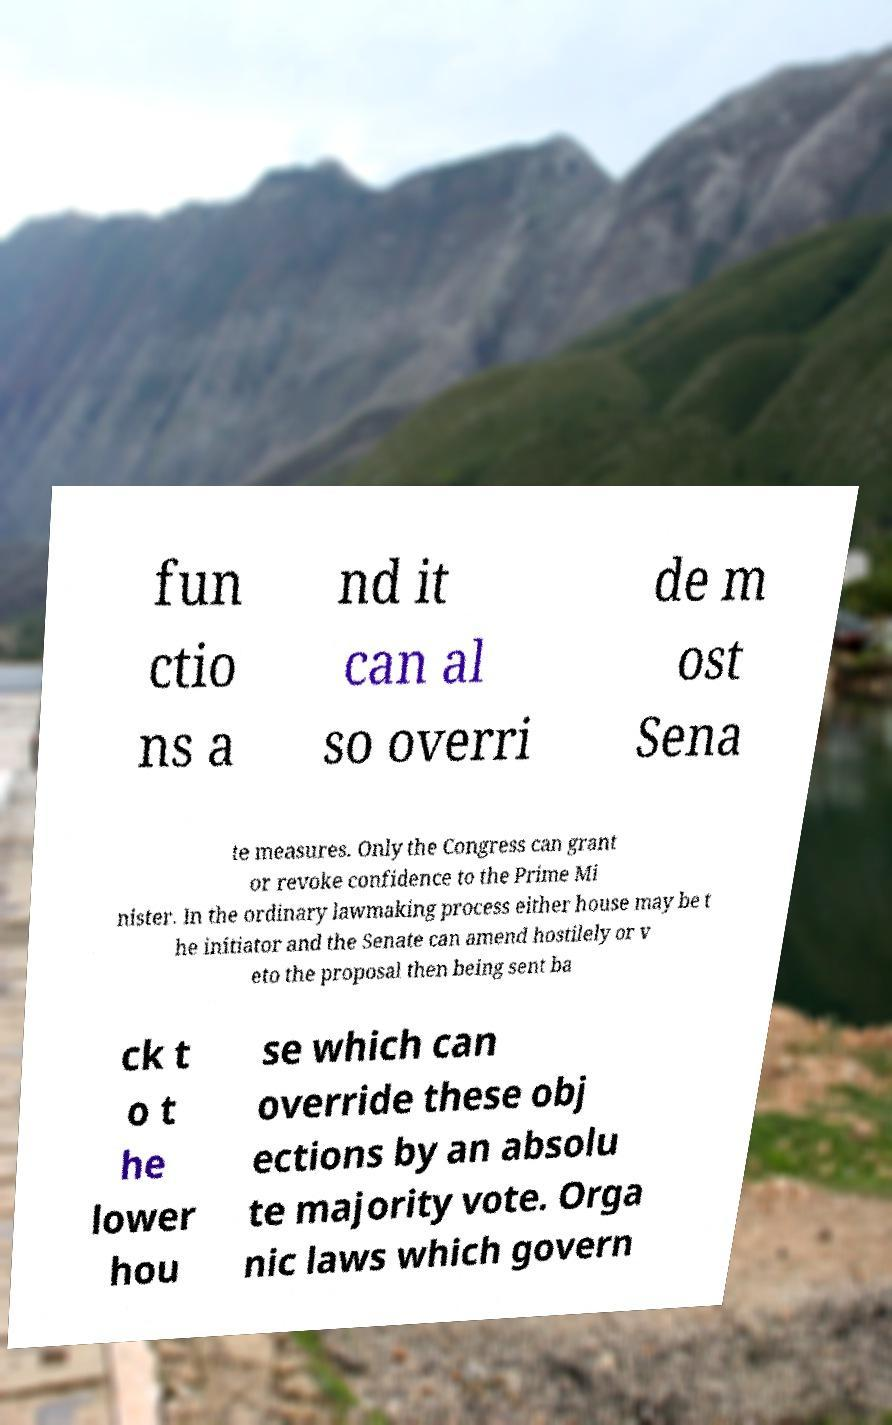Could you extract and type out the text from this image? fun ctio ns a nd it can al so overri de m ost Sena te measures. Only the Congress can grant or revoke confidence to the Prime Mi nister. In the ordinary lawmaking process either house may be t he initiator and the Senate can amend hostilely or v eto the proposal then being sent ba ck t o t he lower hou se which can override these obj ections by an absolu te majority vote. Orga nic laws which govern 